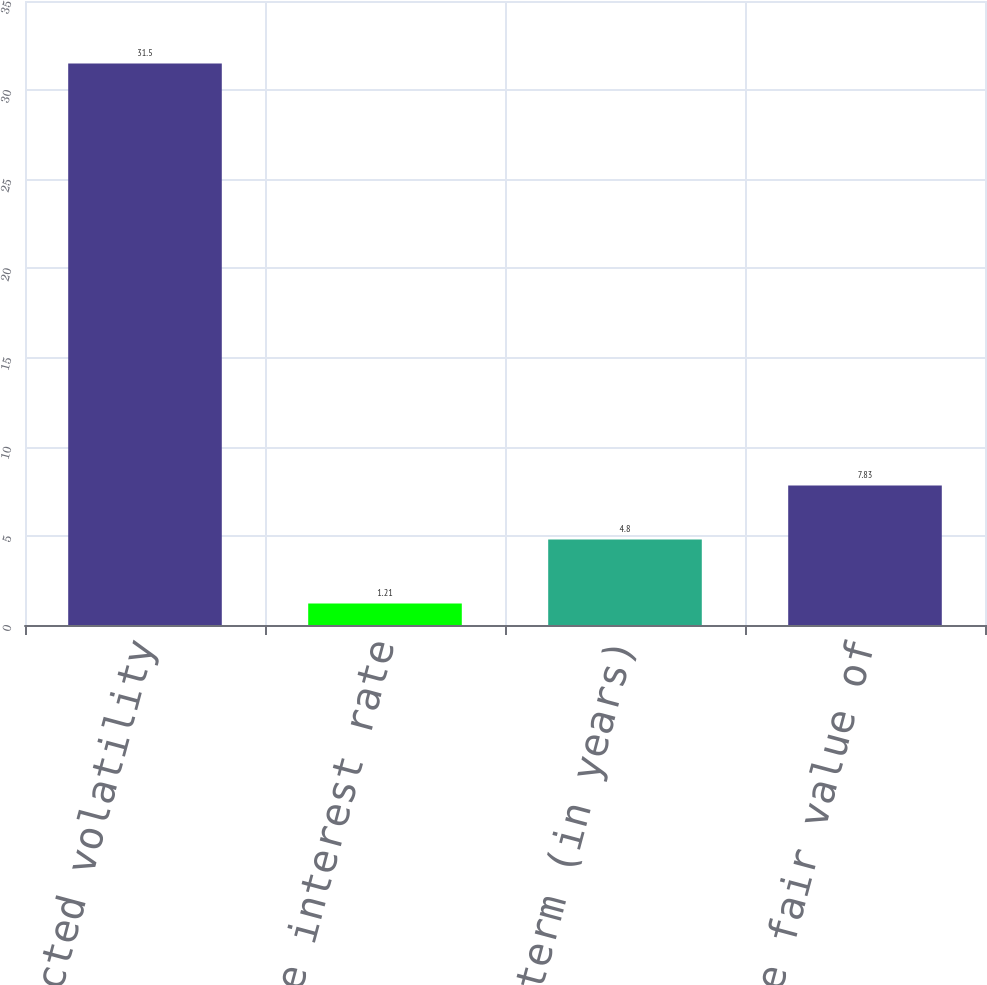Convert chart. <chart><loc_0><loc_0><loc_500><loc_500><bar_chart><fcel>Expected volatility<fcel>Risk-free interest rate<fcel>Expected term (in years)<fcel>Weighted-average fair value of<nl><fcel>31.5<fcel>1.21<fcel>4.8<fcel>7.83<nl></chart> 